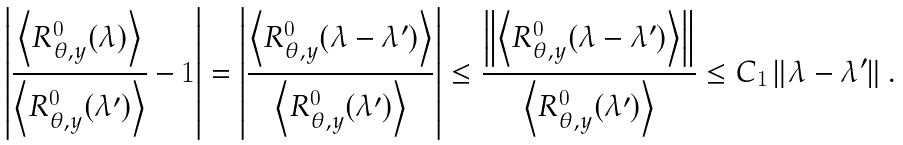<formula> <loc_0><loc_0><loc_500><loc_500>\left | \frac { \left \langle R _ { \theta , y } ^ { \boldsymbol 0 } ( \lambda ) \right \rangle } { \left \langle R _ { \theta , y } ^ { \boldsymbol 0 } ( \lambda ^ { \prime } ) \right \rangle } - 1 \right | = \left | \frac { \left \langle R _ { \theta , y } ^ { \boldsymbol 0 } ( \lambda - \lambda ^ { \prime } ) \right \rangle } { \left \langle R _ { \theta , y } ^ { \boldsymbol 0 } ( \lambda ^ { \prime } ) \right \rangle } \right | \leq \frac { \left \| \left \langle R _ { \theta , y } ^ { \boldsymbol 0 } ( \lambda - \lambda ^ { \prime } ) \right \rangle \right \| } { \left \langle R _ { \theta , y } ^ { \boldsymbol 0 } ( \lambda ^ { \prime } ) \right \rangle } \leq C _ { 1 } \left \| \lambda - \lambda ^ { \prime } \right \| .</formula> 